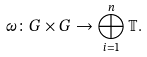<formula> <loc_0><loc_0><loc_500><loc_500>\omega \colon G \times G \to \bigoplus _ { i = 1 } ^ { n } \mathbb { T } .</formula> 